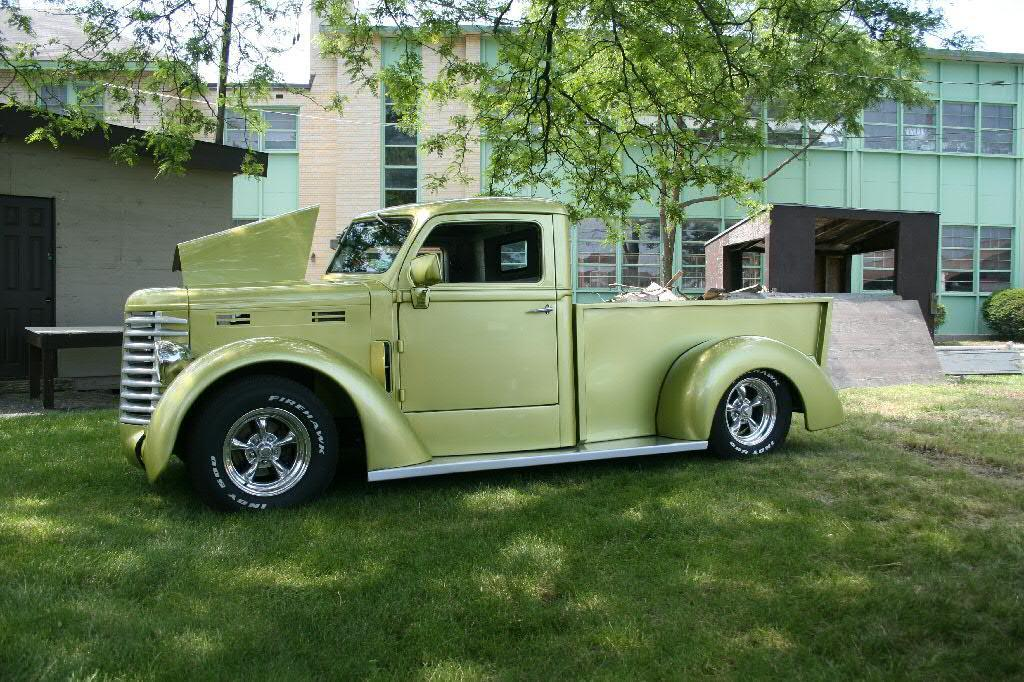What is parked on the grass path in the image? There is a vehicle parked on the grass path in the image. What is located behind the vehicle? There is a table and a shed behind the vehicle. What can be seen in the background of the image? Buildings, trees, and the sky are visible in the background of the image. How does the vehicle compare to the road in the image? There is no road present in the image, so it cannot be compared to the vehicle. 